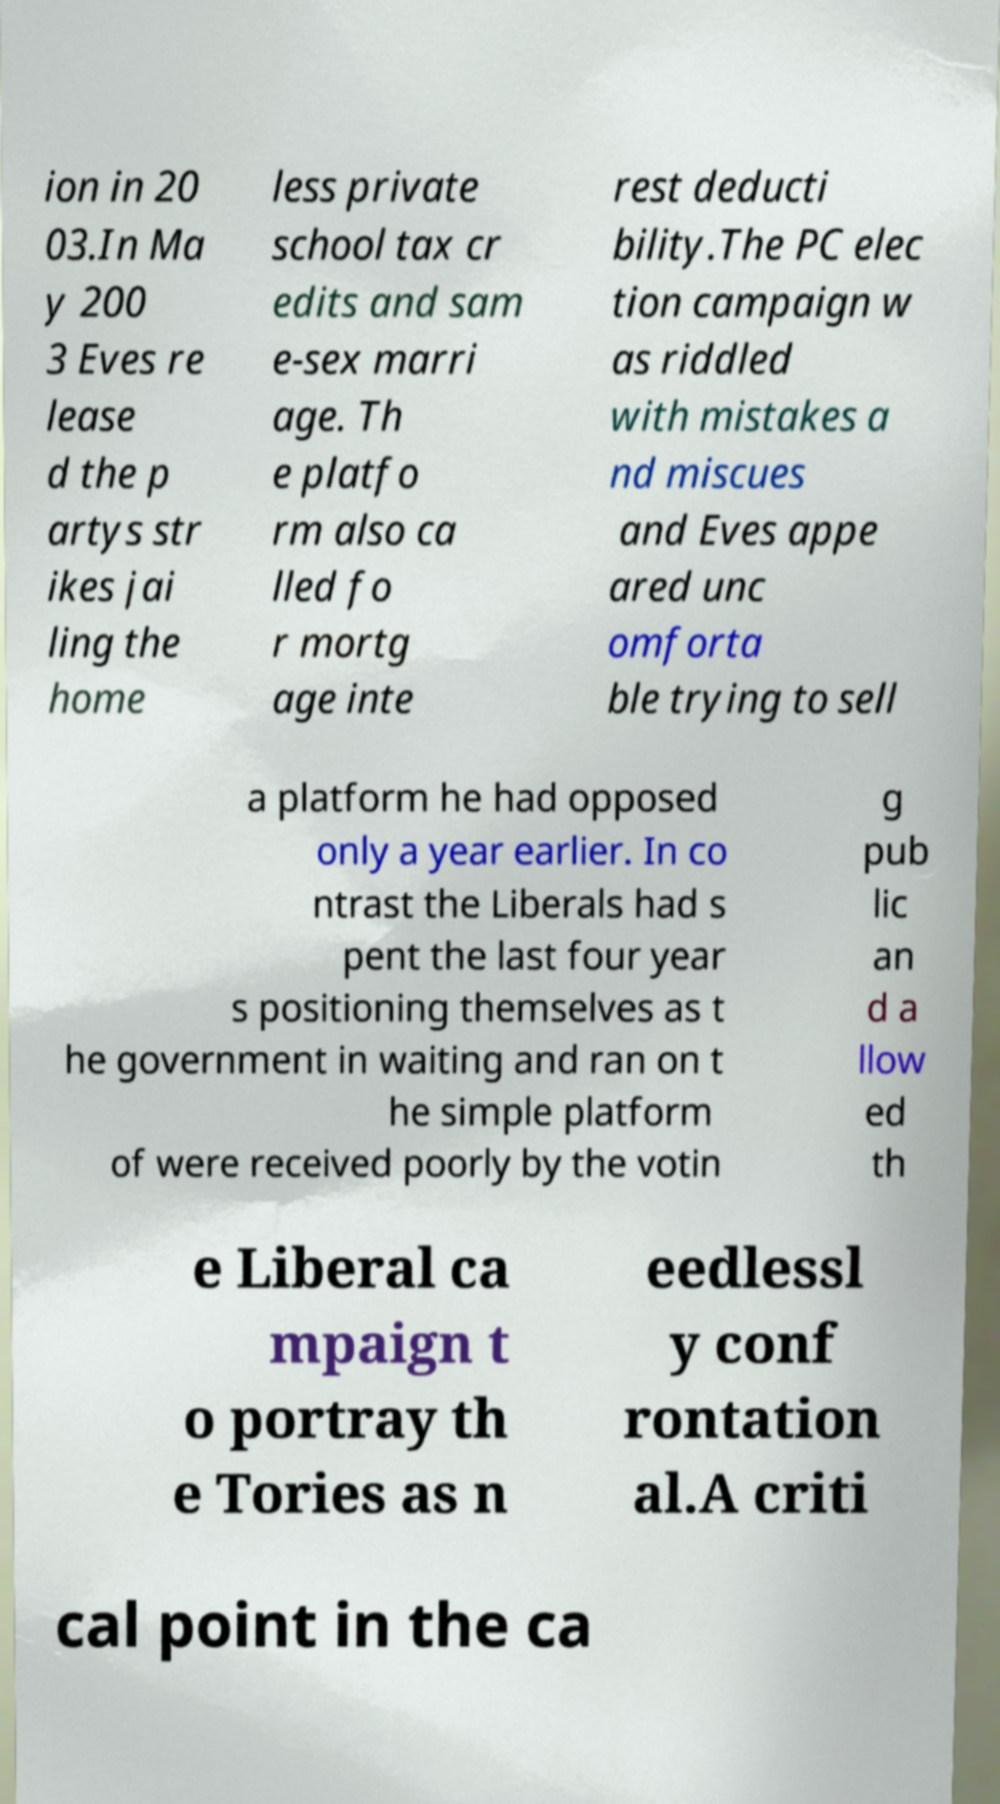Please read and relay the text visible in this image. What does it say? ion in 20 03.In Ma y 200 3 Eves re lease d the p artys str ikes jai ling the home less private school tax cr edits and sam e-sex marri age. Th e platfo rm also ca lled fo r mortg age inte rest deducti bility.The PC elec tion campaign w as riddled with mistakes a nd miscues and Eves appe ared unc omforta ble trying to sell a platform he had opposed only a year earlier. In co ntrast the Liberals had s pent the last four year s positioning themselves as t he government in waiting and ran on t he simple platform of were received poorly by the votin g pub lic an d a llow ed th e Liberal ca mpaign t o portray th e Tories as n eedlessl y conf rontation al.A criti cal point in the ca 